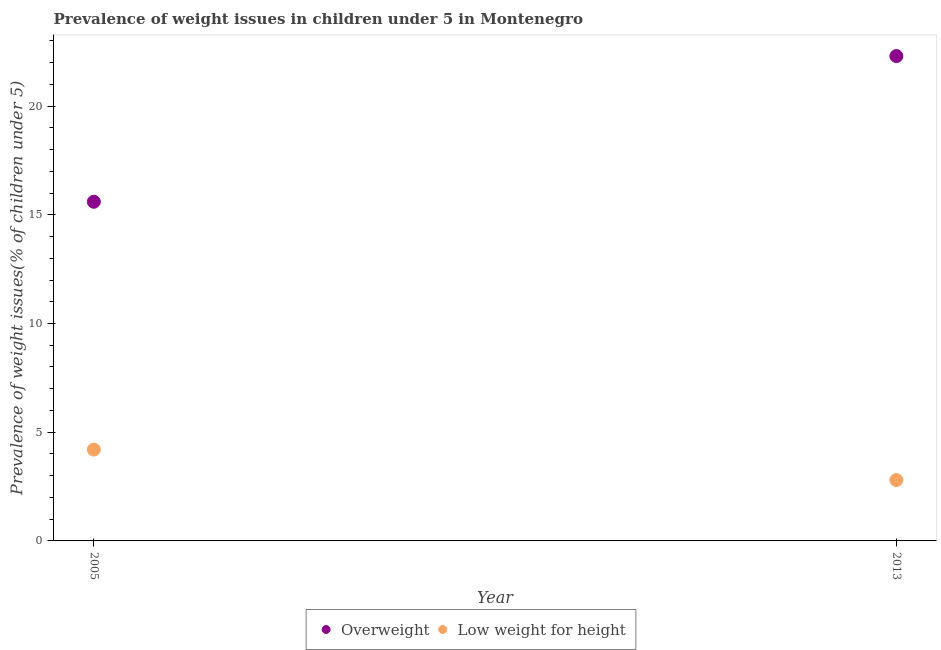How many different coloured dotlines are there?
Make the answer very short. 2. Is the number of dotlines equal to the number of legend labels?
Your response must be concise. Yes. What is the percentage of overweight children in 2013?
Make the answer very short. 22.3. Across all years, what is the maximum percentage of underweight children?
Provide a succinct answer. 4.2. Across all years, what is the minimum percentage of overweight children?
Give a very brief answer. 15.6. In which year was the percentage of overweight children minimum?
Your response must be concise. 2005. What is the total percentage of underweight children in the graph?
Your answer should be very brief. 7. What is the difference between the percentage of underweight children in 2005 and that in 2013?
Offer a very short reply. 1.4. What is the difference between the percentage of overweight children in 2013 and the percentage of underweight children in 2005?
Provide a short and direct response. 18.1. What is the average percentage of underweight children per year?
Ensure brevity in your answer.  3.5. In the year 2013, what is the difference between the percentage of underweight children and percentage of overweight children?
Ensure brevity in your answer.  -19.5. What is the ratio of the percentage of underweight children in 2005 to that in 2013?
Ensure brevity in your answer.  1.5. Is the percentage of underweight children in 2005 less than that in 2013?
Ensure brevity in your answer.  No. Does the percentage of underweight children monotonically increase over the years?
Give a very brief answer. No. Is the percentage of overweight children strictly greater than the percentage of underweight children over the years?
Offer a terse response. Yes. How many dotlines are there?
Offer a terse response. 2. Are the values on the major ticks of Y-axis written in scientific E-notation?
Make the answer very short. No. Does the graph contain any zero values?
Ensure brevity in your answer.  No. Where does the legend appear in the graph?
Your response must be concise. Bottom center. What is the title of the graph?
Make the answer very short. Prevalence of weight issues in children under 5 in Montenegro. What is the label or title of the Y-axis?
Make the answer very short. Prevalence of weight issues(% of children under 5). What is the Prevalence of weight issues(% of children under 5) of Overweight in 2005?
Your answer should be very brief. 15.6. What is the Prevalence of weight issues(% of children under 5) of Low weight for height in 2005?
Provide a succinct answer. 4.2. What is the Prevalence of weight issues(% of children under 5) in Overweight in 2013?
Provide a short and direct response. 22.3. What is the Prevalence of weight issues(% of children under 5) of Low weight for height in 2013?
Your response must be concise. 2.8. Across all years, what is the maximum Prevalence of weight issues(% of children under 5) in Overweight?
Make the answer very short. 22.3. Across all years, what is the maximum Prevalence of weight issues(% of children under 5) in Low weight for height?
Offer a terse response. 4.2. Across all years, what is the minimum Prevalence of weight issues(% of children under 5) of Overweight?
Your answer should be compact. 15.6. Across all years, what is the minimum Prevalence of weight issues(% of children under 5) of Low weight for height?
Your answer should be compact. 2.8. What is the total Prevalence of weight issues(% of children under 5) of Overweight in the graph?
Offer a very short reply. 37.9. What is the difference between the Prevalence of weight issues(% of children under 5) of Overweight in 2005 and the Prevalence of weight issues(% of children under 5) of Low weight for height in 2013?
Your answer should be very brief. 12.8. What is the average Prevalence of weight issues(% of children under 5) in Overweight per year?
Your response must be concise. 18.95. In the year 2005, what is the difference between the Prevalence of weight issues(% of children under 5) of Overweight and Prevalence of weight issues(% of children under 5) of Low weight for height?
Keep it short and to the point. 11.4. What is the ratio of the Prevalence of weight issues(% of children under 5) of Overweight in 2005 to that in 2013?
Give a very brief answer. 0.7. What is the ratio of the Prevalence of weight issues(% of children under 5) of Low weight for height in 2005 to that in 2013?
Your answer should be compact. 1.5. What is the difference between the highest and the lowest Prevalence of weight issues(% of children under 5) of Overweight?
Your answer should be compact. 6.7. 